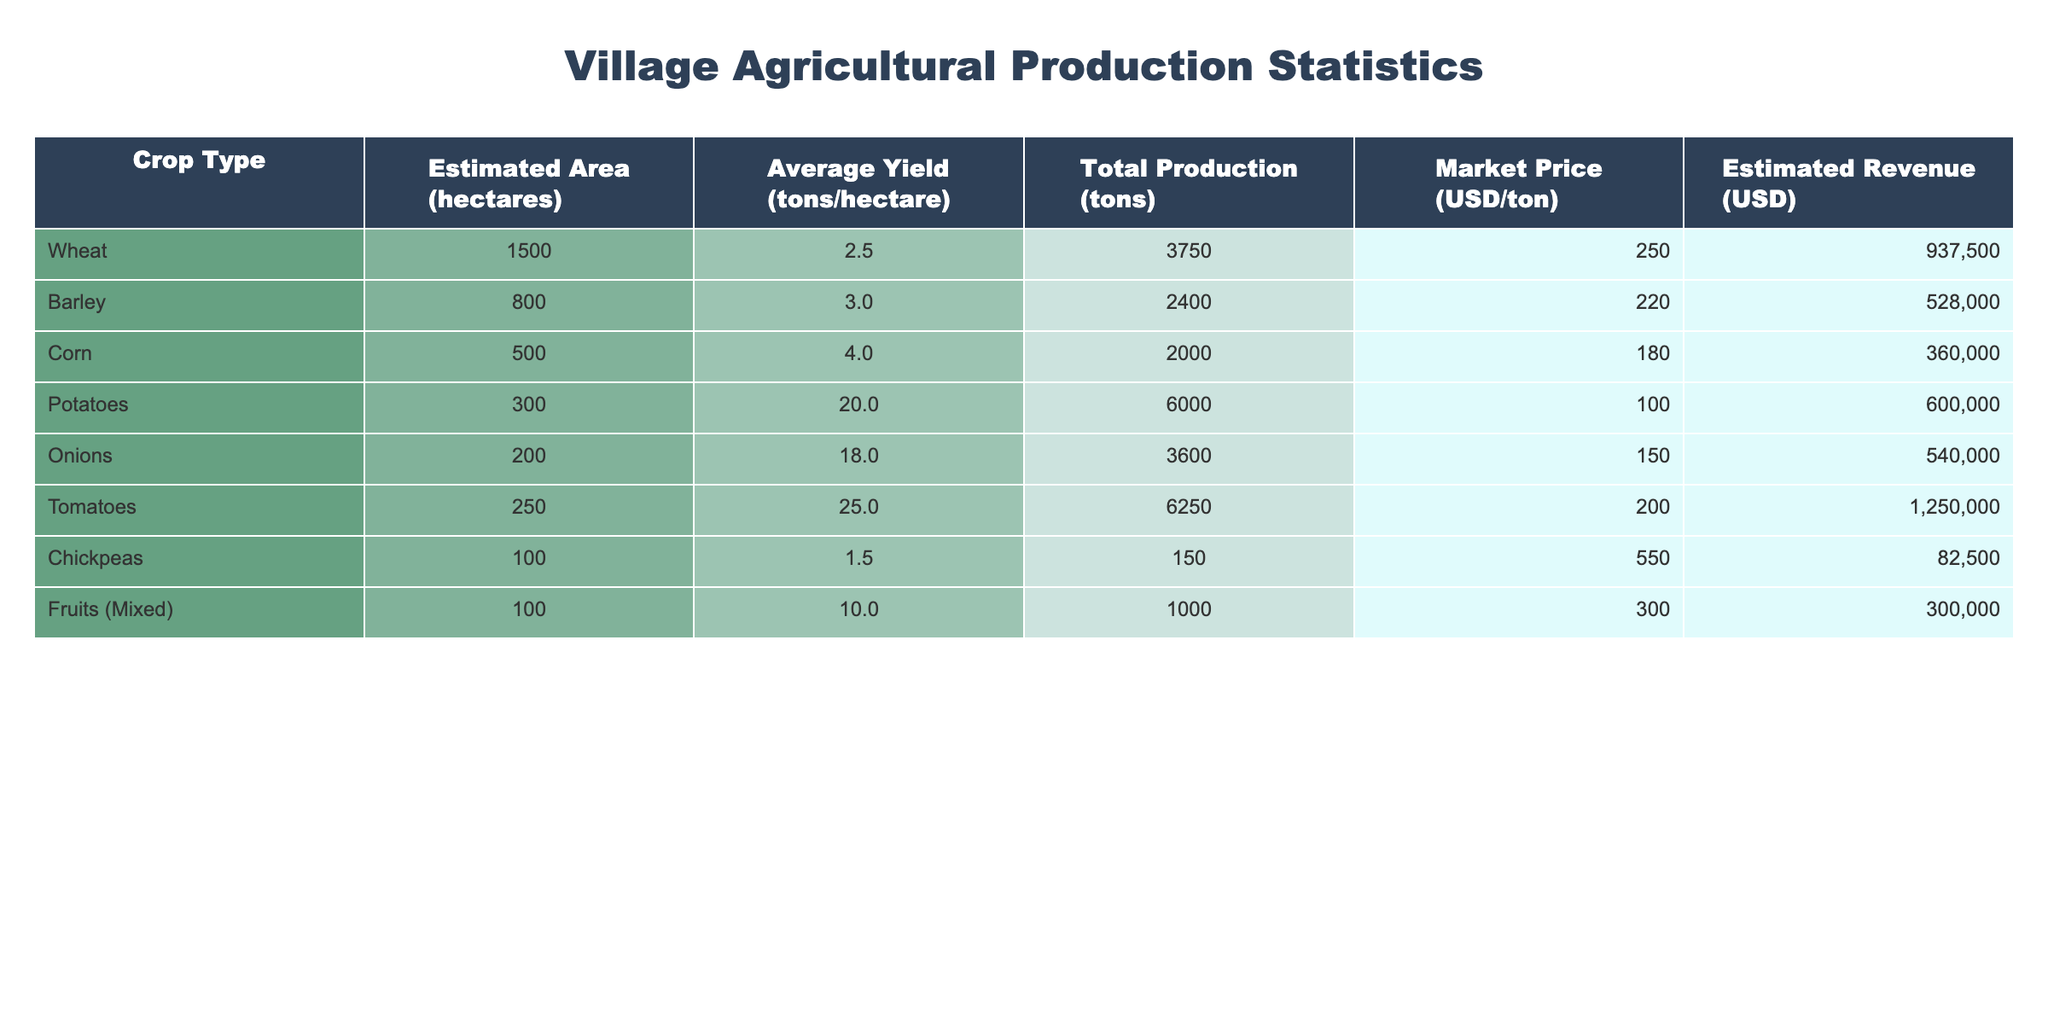What is the total production of wheat? The table lists the total production for each crop type. For wheat, the total production is given directly as 3750 tons.
Answer: 3750 tons Which crop has the highest average yield per hectare? By examining the average yield column, I see that potatoes have the highest average yield at 20.0 tons/hectare, compared to other crops.
Answer: Potatoes with 20.0 tons/hectare What is the total estimated revenue from tomatoes? The estimated revenue listed for tomatoes in the table is 1,250,000 USD. This value is taken directly from the revenue column corresponding to tomatoes.
Answer: 1,250,000 USD How much more total production do potatoes have compared to barley? The total production of potatoes is 6000 tons, while barley has 2400 tons. To find the difference, I subtract the two values: 6000 - 2400 = 3600 tons more for potatoes.
Answer: 3600 tons Is the market price of corn higher than that of chickpeas? The market price for corn is 180 USD/ton, and for chickpeas, it is 550 USD/ton. Since 180 is less than 550, the statement is false.
Answer: No What is the average total production of all crops combined? First, I sum the total production for all crops: 3750 + 2400 + 2000 + 6000 + 3600 + 6250 + 150 + 1000 = 22,150 tons. Then, I divide by the number of crops, which is 8: 22,150 / 8 = 2768.75 tons.
Answer: 2768.75 tons If the estimated area for tomatoes were reduced by half, what would the new total production be using the current average yield? The current estimated area for tomatoes is 250 hectares with an average yield of 25.0 tons/hectare. If I reduce the area by half, it becomes 125 hectares. Now, I multiply 125 hectares by the yield: 125 * 25.0 = 3125 tons.
Answer: 3125 tons What crop type contributes the least to the total revenue? When looking at the revenue column, chickpeas have the revenue value of 82,500 USD, which is the lowest compared to other crops' revenues.
Answer: Chickpeas What is the difference in market price between onions and potatoes? The market price for onions is 150 USD/ton and for potatoes, it's 100 USD/ton. To find the difference, I subtract: 150 - 100 = 50 USD.
Answer: 50 USD 